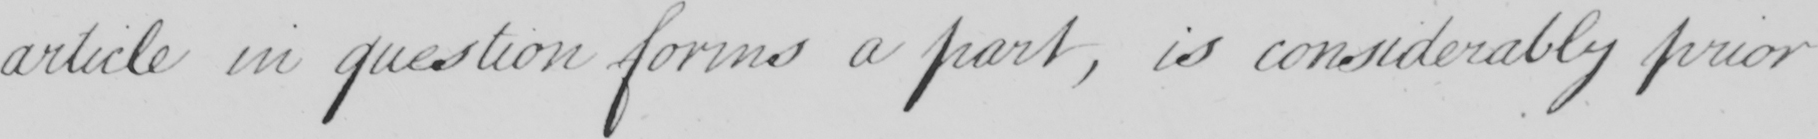What does this handwritten line say? article in question forms a part , is considerably prior 